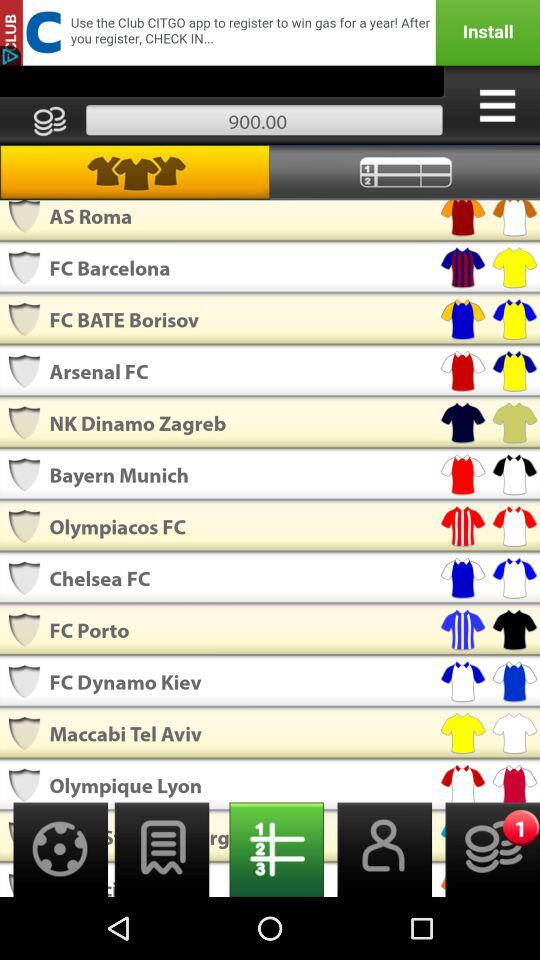What can you infer about the app displayed in the image? The app shown in the image appears to be a sports-related mobile application, possibly for keeping track of sports scores or managing fantasy football teams. The app lists different football clubs along with some representations, suggesting features like team selection or performance tracking. Is there any indication of the app's purpose based on the design? Based on the design, with the clubs listed and the presence of a numerical score at the top, the app could be intended for managing or participating in a fantasy football league, where users could presumably select teams and earn points based on real match outcomes. 